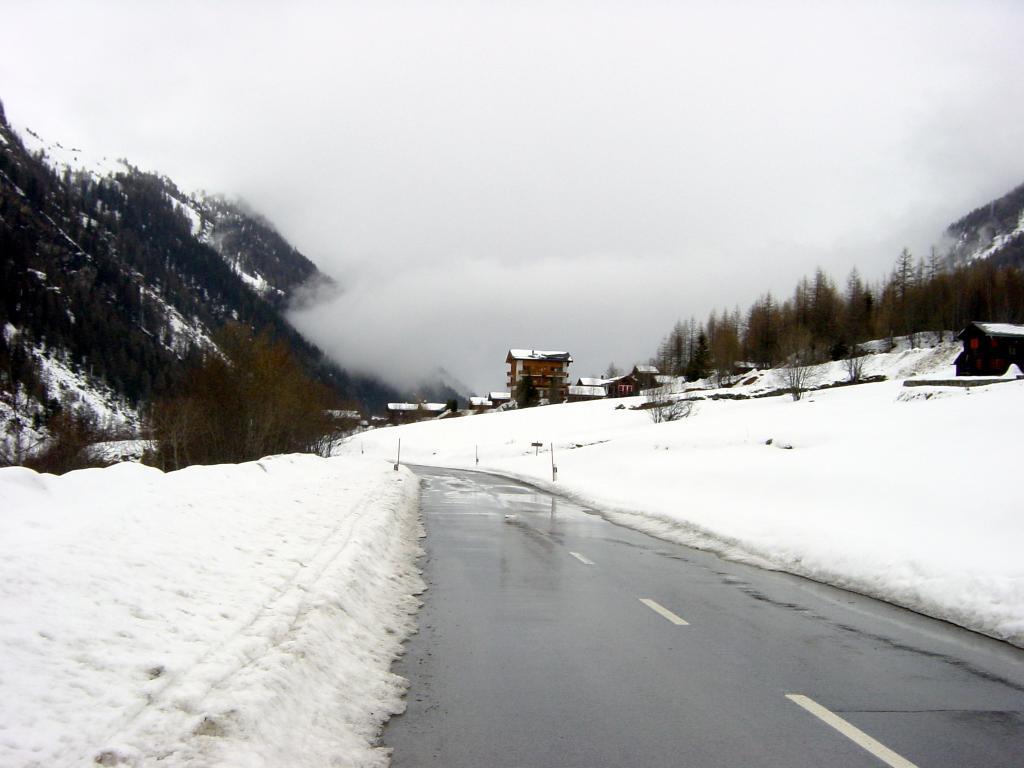Please provide a concise description of this image. In this picture we can see a road and on the right side of the road there are houses, trees, hills and snow. Behind the houses there is fog. 